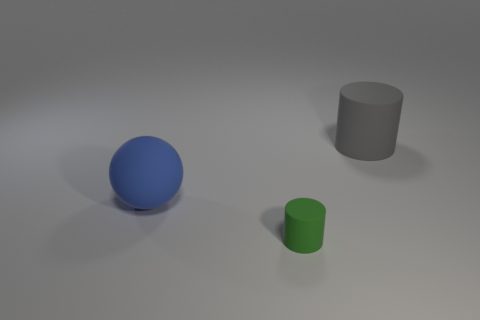Add 2 red blocks. How many objects exist? 5 Subtract all balls. How many objects are left? 2 Add 2 gray cylinders. How many gray cylinders exist? 3 Subtract 0 cyan blocks. How many objects are left? 3 Subtract all rubber objects. Subtract all large brown matte spheres. How many objects are left? 0 Add 1 matte objects. How many matte objects are left? 4 